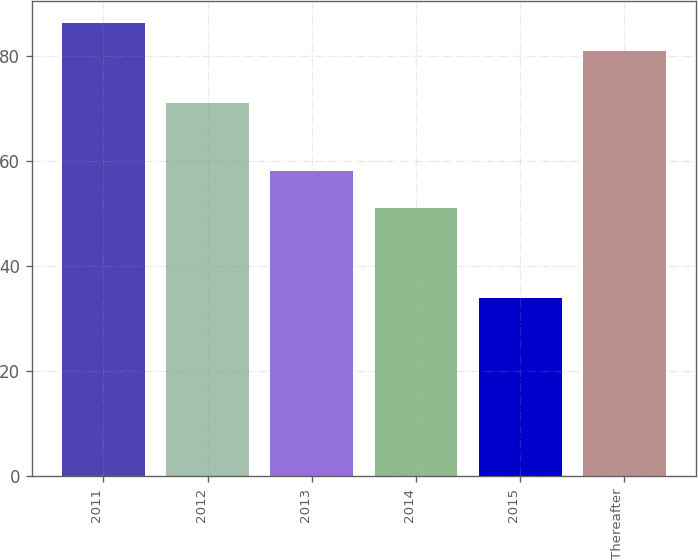Convert chart. <chart><loc_0><loc_0><loc_500><loc_500><bar_chart><fcel>2011<fcel>2012<fcel>2013<fcel>2014<fcel>2015<fcel>Thereafter<nl><fcel>86.2<fcel>71<fcel>58<fcel>51<fcel>34<fcel>81<nl></chart> 